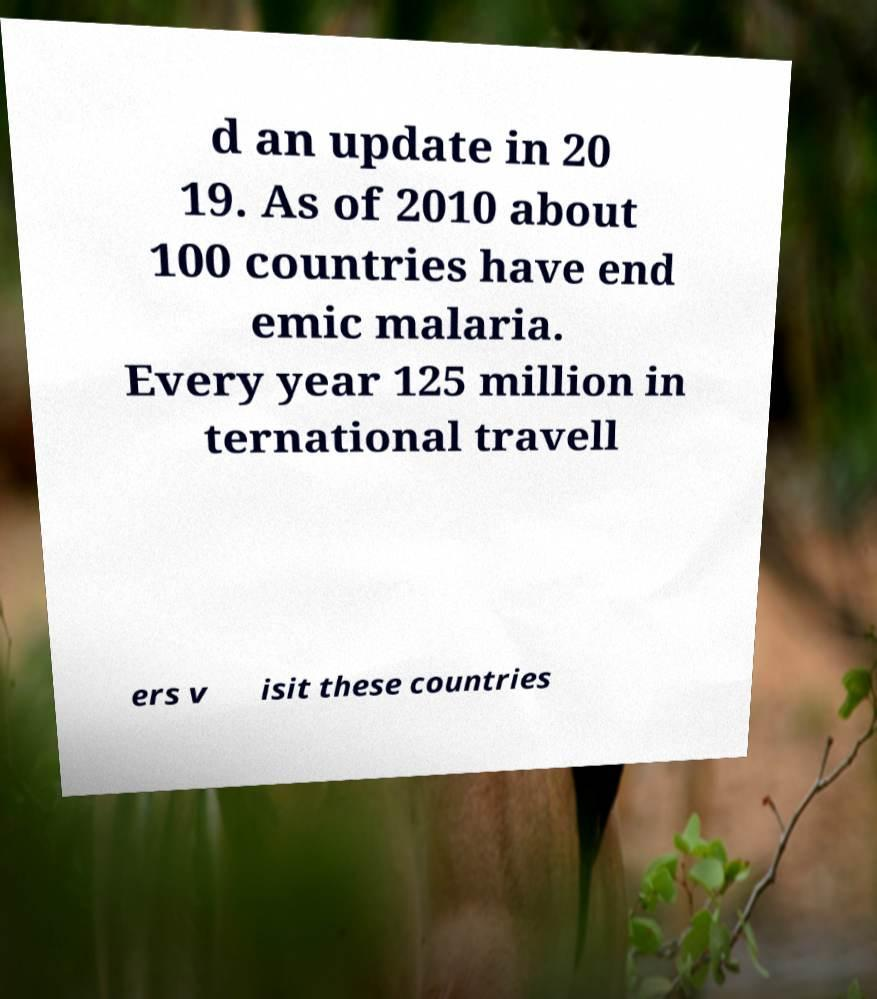Can you read and provide the text displayed in the image?This photo seems to have some interesting text. Can you extract and type it out for me? d an update in 20 19. As of 2010 about 100 countries have end emic malaria. Every year 125 million in ternational travell ers v isit these countries 